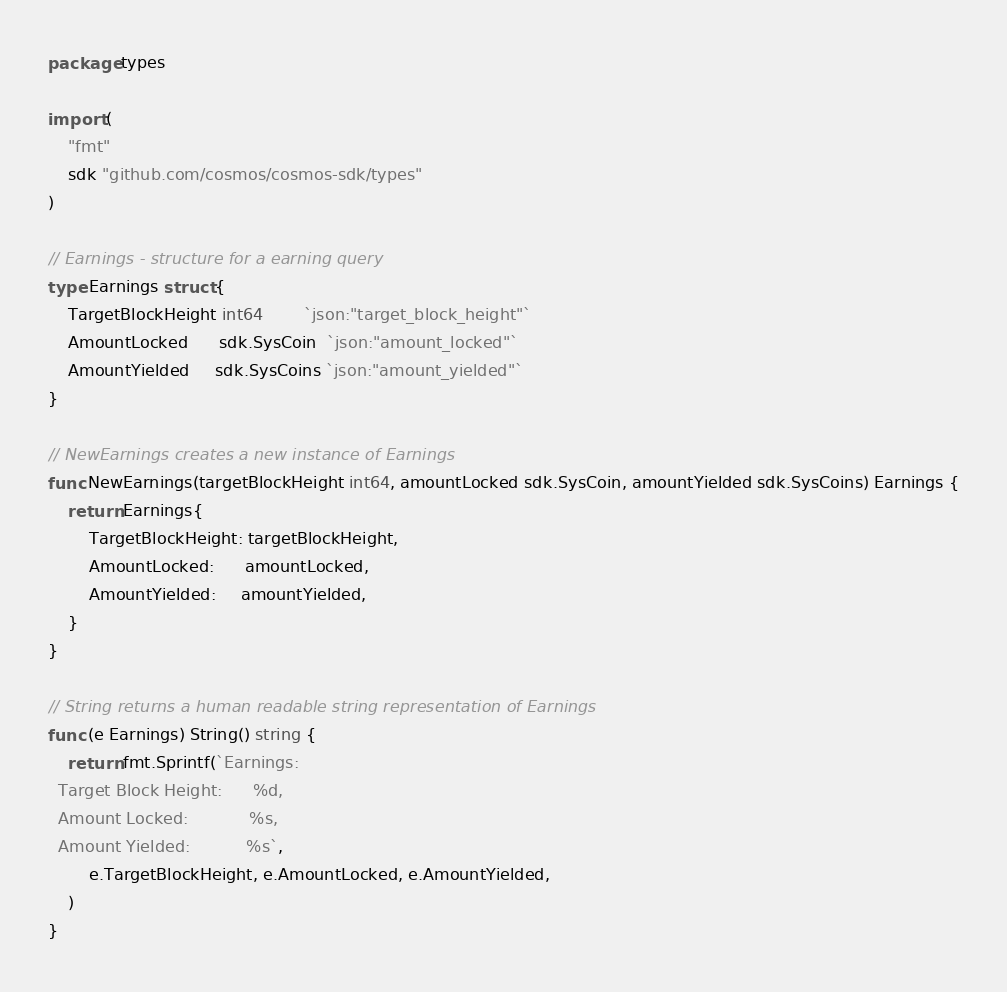Convert code to text. <code><loc_0><loc_0><loc_500><loc_500><_Go_>package types

import (
	"fmt"
	sdk "github.com/cosmos/cosmos-sdk/types"
)

// Earnings - structure for a earning query
type Earnings struct {
	TargetBlockHeight int64        `json:"target_block_height"`
	AmountLocked      sdk.SysCoin  `json:"amount_locked"`
	AmountYielded     sdk.SysCoins `json:"amount_yielded"`
}

// NewEarnings creates a new instance of Earnings
func NewEarnings(targetBlockHeight int64, amountLocked sdk.SysCoin, amountYielded sdk.SysCoins) Earnings {
	return Earnings{
		TargetBlockHeight: targetBlockHeight,
		AmountLocked:      amountLocked,
		AmountYielded:     amountYielded,
	}
}

// String returns a human readable string representation of Earnings
func (e Earnings) String() string {
	return fmt.Sprintf(`Earnings:
  Target Block Height: 		%d,
  Amount Locked:			%s,
  Amount Yielded:			%s`,
		e.TargetBlockHeight, e.AmountLocked, e.AmountYielded,
	)
}
</code> 